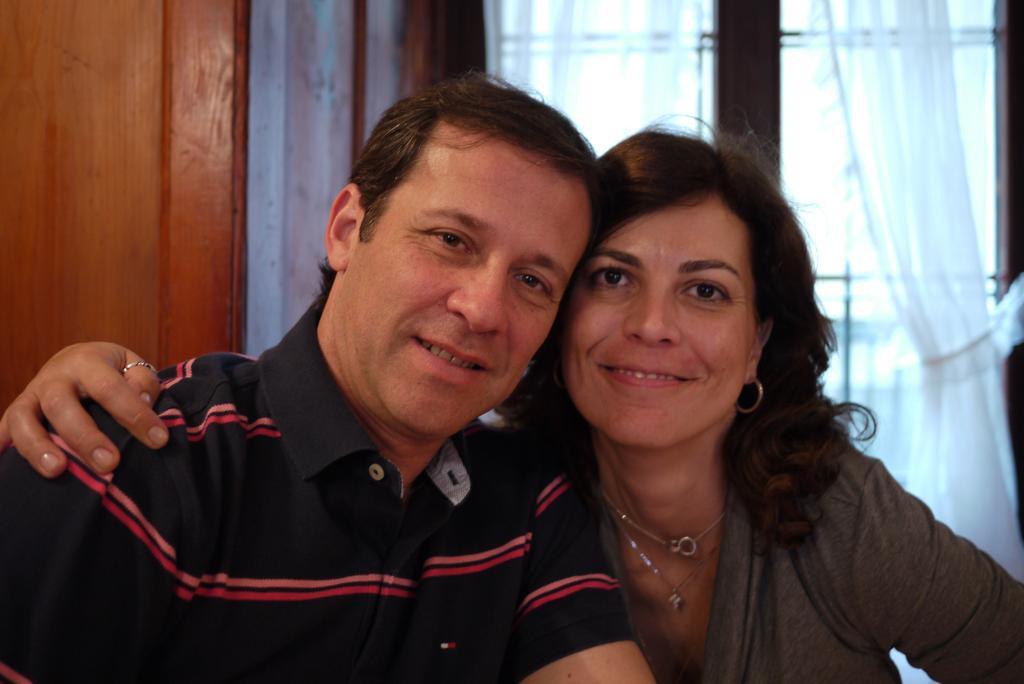Can you describe this image briefly? In the image we can see there are people and behind there are curtains on the window. 